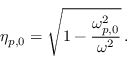<formula> <loc_0><loc_0><loc_500><loc_500>\eta _ { p , 0 } = \sqrt { 1 - \frac { \omega _ { p , 0 } ^ { 2 } } { \omega ^ { 2 } } } \, .</formula> 